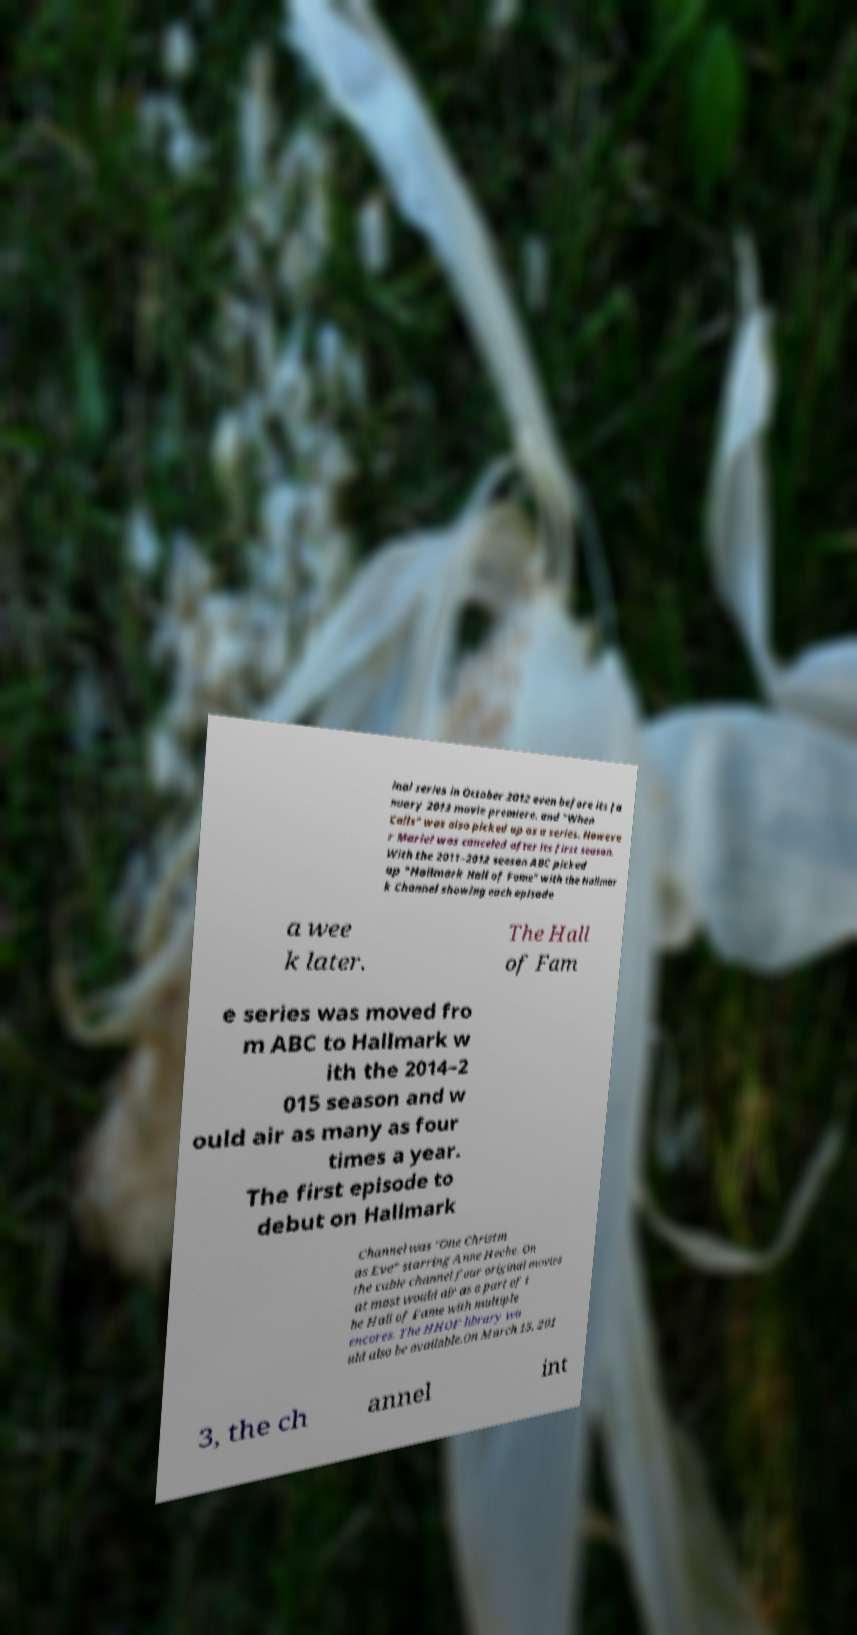Could you extract and type out the text from this image? inal series in October 2012 even before its Ja nuary 2013 movie premiere. and "When Calls" was also picked up as a series. Howeve r Marie! was canceled after its first season. With the 2011–2012 season ABC picked up "Hallmark Hall of Fame" with the Hallmar k Channel showing each episode a wee k later. The Hall of Fam e series was moved fro m ABC to Hallmark w ith the 2014–2 015 season and w ould air as many as four times a year. The first episode to debut on Hallmark Channel was "One Christm as Eve" starring Anne Heche. On the cable channel four original movies at most would air as a part of t he Hall of Fame with multiple encores. The HHOF library wo uld also be available.On March 15, 201 3, the ch annel int 